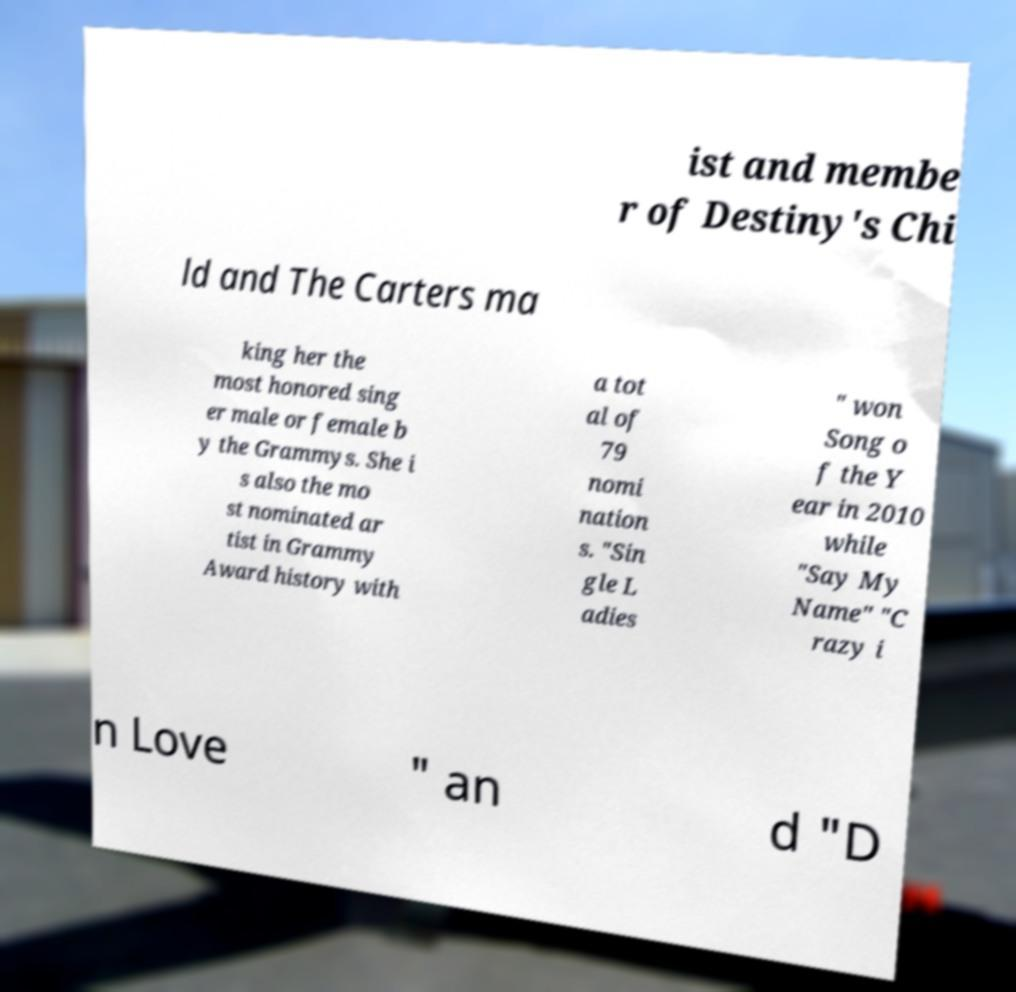Could you assist in decoding the text presented in this image and type it out clearly? ist and membe r of Destiny's Chi ld and The Carters ma king her the most honored sing er male or female b y the Grammys. She i s also the mo st nominated ar tist in Grammy Award history with a tot al of 79 nomi nation s. "Sin gle L adies " won Song o f the Y ear in 2010 while "Say My Name" "C razy i n Love " an d "D 